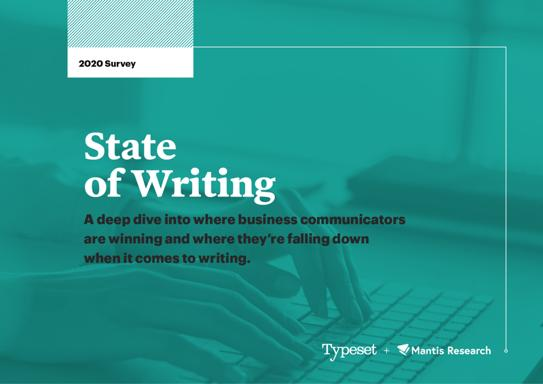How has the field of business writing evolved according to the findings of the 2020 survey? According to the survey, business writing has seen an increased emphasis on precision and brevity. With digital communication becoming more prevalent, the necessity for clear, concise, and compelling writing is more important than ever to capture and retain audience interest. 